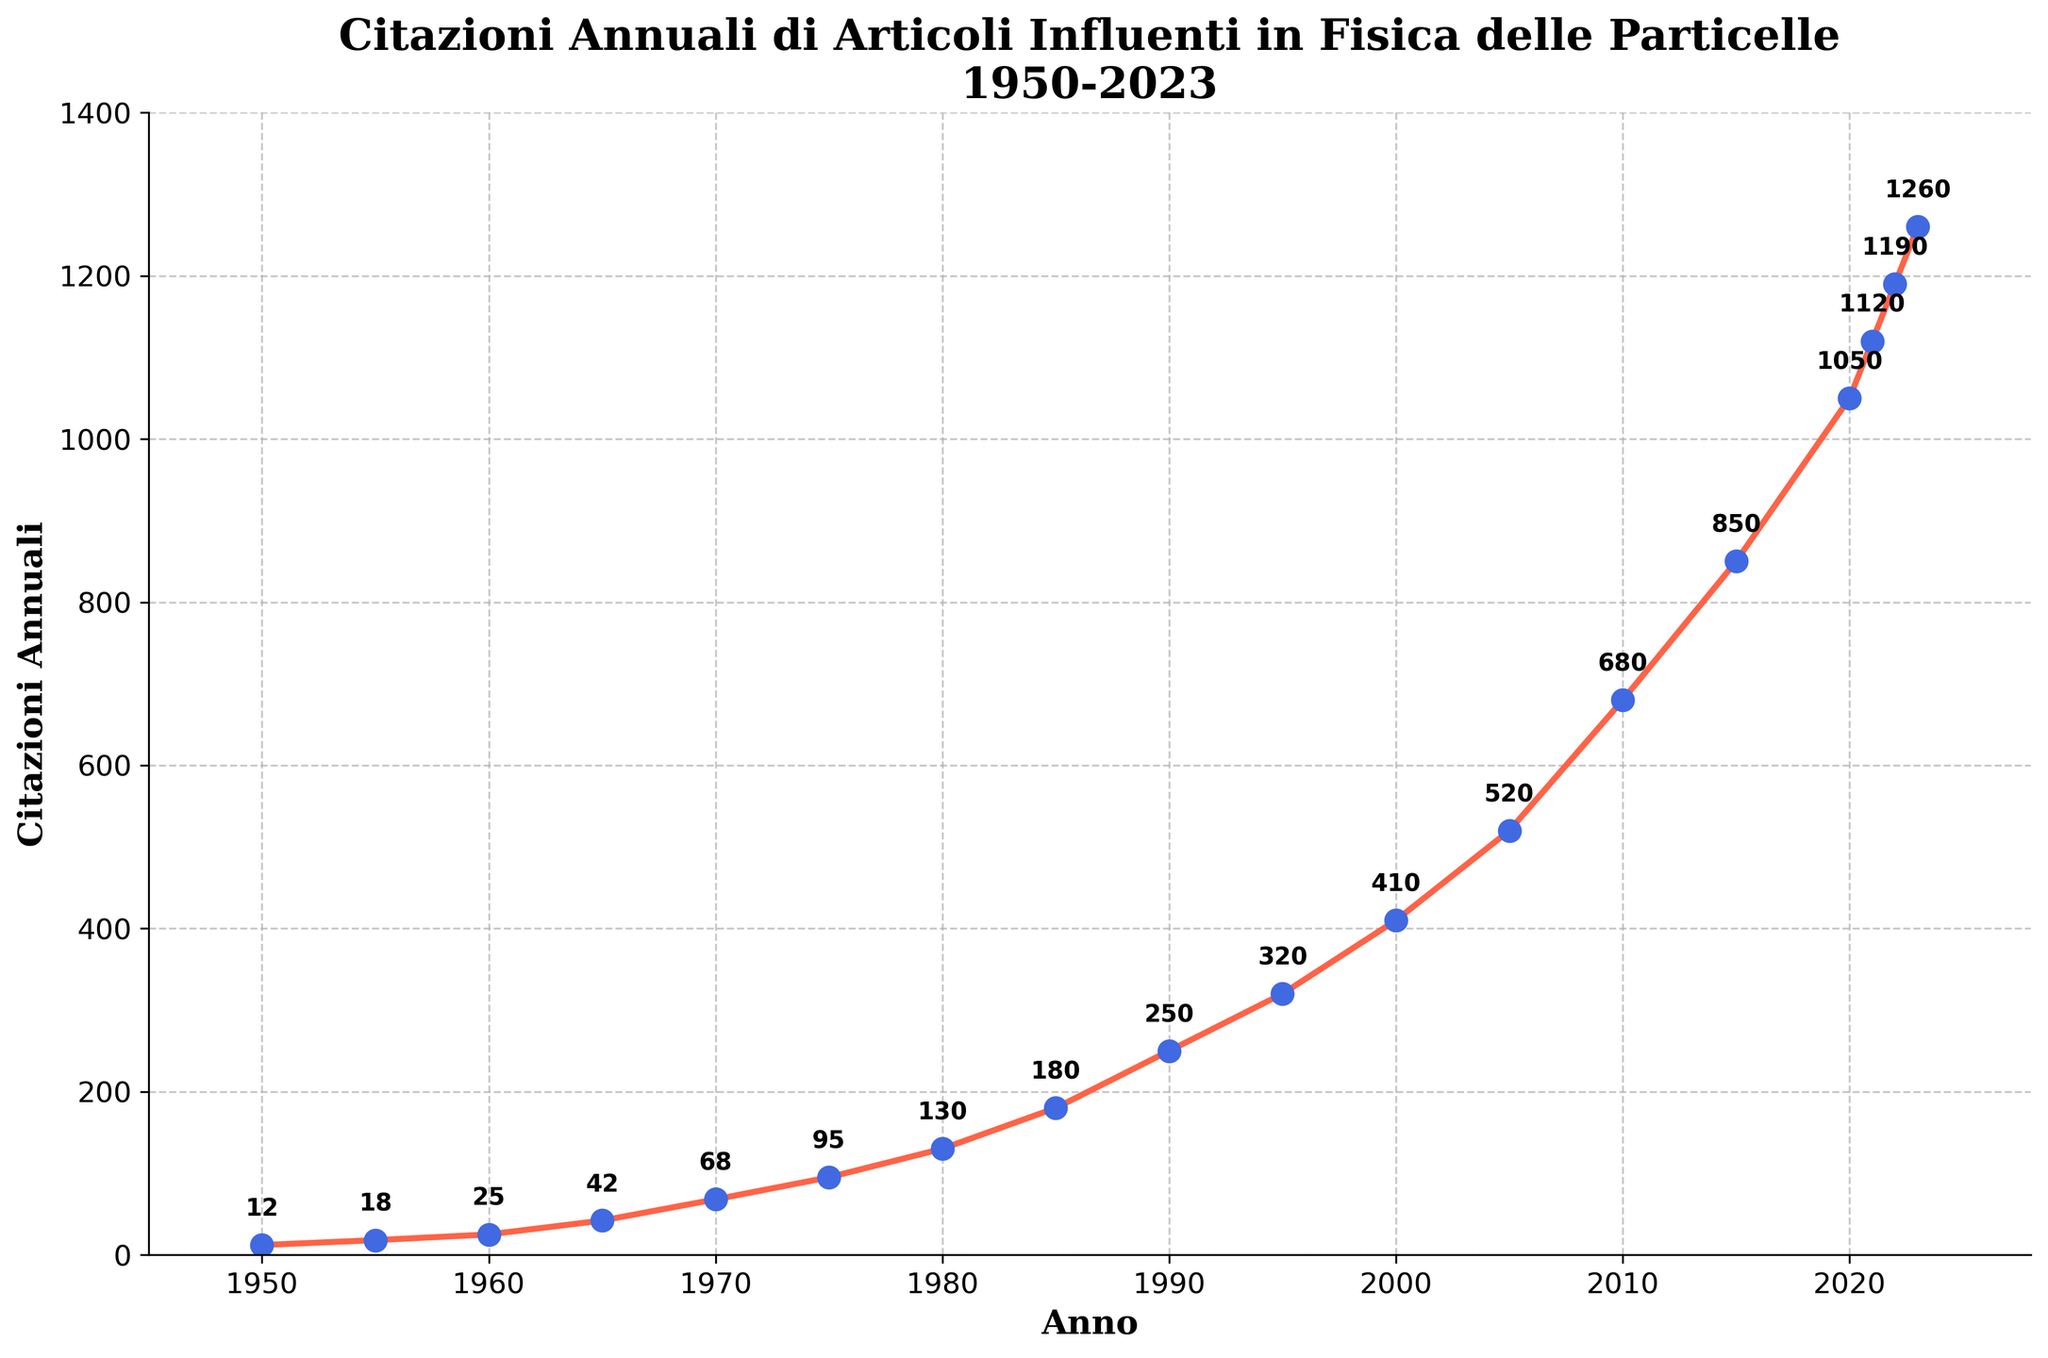**How many more citations were there in 2023 compared to 1950?** To find the increase in citations from 1950 to 2023, subtract the number of citations in 1950 from those in 2023: 1260 (2023) - 12 (1950) = 1248
Answer: 1248 **What was the percentage increase in citations from 2000 to 2020?** First, find the difference in citations between the two years: 1050 (2020) - 410 (2000) = 640. Then, divide the difference by the citation count in 2000 and multiply by 100: (640 / 410) * 100 ≈ 156.10%
Answer: 156.10% **Which year had the highest number of citations?** Look at the figure and identify the year with the highest point on the y-axis. In this case, it is 2023 with 1260 citations.
Answer: 2023 **By how much did the citations increase from 1990 to 1995?** Subtract the number of citations in 1990 from the number in 1995: 320 (1995) - 250 (1990) = 70
Answer: 70 **In which decade did the citations see the most significant growth?** Compare the growth in citations across different decades by observing the steepness of the slope. The decade from 2000 to 2010 had a notable increase from 410 to 680 citations. The biggest jump, however, is from 2010 to 2020, where citations increased from 680 to 1050.
Answer: 2010s **What is the average annual citation count in the 21st century (2000-2023)?** Add the citation counts from 2000 to 2023 and divide by the number of years (24): (410 + 520 + 680 + 850 + 1050 + 1120 + 1190 + 1260) / 24 ≈ 761.5
Answer: 761.5 **Did the citation count ever decrease from one five-year period to the next?** Examine the chart to see if the citation count ever drops in any of the five-year intervals. The chart shows a consistent increase with no decreases.
Answer: No **What is the average increase in citations per year between 1980 and 1990?** First, calculate the total increase from 1980 to 1990: 250 (1990) - 130 (1980) = 120. Then, divide this by the number of years: 120 / 10 = 12
Answer: 12 **How many years did it take for the citations to surpass 1000 from 1950?** Identify when the citations first exceeded 1000, which is in 2020. Then calculate the number of years from 1950 to 2020: 2020 - 1950 = 70 years.
Answer: 70 **Is there a noticeable trend or pattern in how the citation counts change over the years?** Evaluate the general direction and shape of the line plot. The citation counts show an exponential growth trend, with the rate of increase becoming more rapid over time. This is evident from the curved shape of the line.
Answer: Exponential growth 